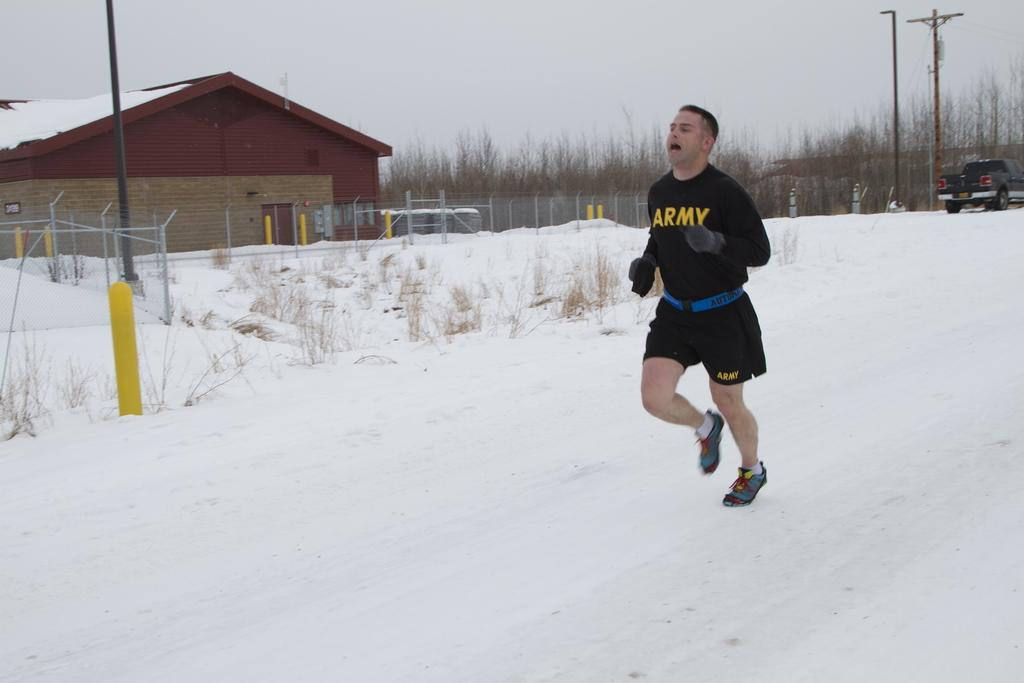<image>
Present a compact description of the photo's key features. A man is running and wearing an Army sweatshirt. 